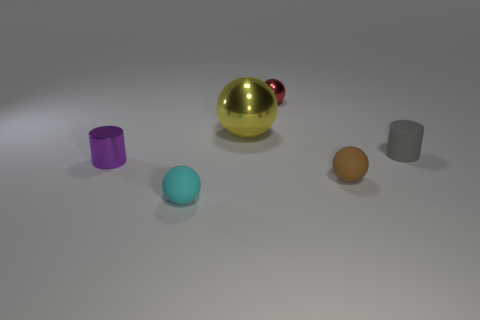There is a tiny metal thing that is to the right of the cylinder that is in front of the cylinder that is on the right side of the tiny metallic ball; what is its shape?
Make the answer very short. Sphere. Are any cylinders visible?
Offer a terse response. Yes. Does the red metallic sphere have the same size as the brown thing right of the large ball?
Ensure brevity in your answer.  Yes. Are there any tiny gray matte cylinders on the left side of the small thing to the right of the tiny brown ball?
Ensure brevity in your answer.  No. There is a tiny ball that is both to the right of the large yellow metal thing and in front of the big yellow sphere; what is it made of?
Offer a very short reply. Rubber. What color is the small cylinder that is right of the cylinder that is to the left of the tiny ball that is behind the large metal object?
Your answer should be compact. Gray. The metallic ball that is the same size as the gray matte object is what color?
Keep it short and to the point. Red. Is the color of the large object the same as the small cylinder behind the shiny cylinder?
Keep it short and to the point. No. What material is the small ball behind the cylinder in front of the gray matte cylinder made of?
Your answer should be compact. Metal. How many objects are left of the brown sphere and behind the tiny purple shiny object?
Provide a succinct answer. 2. 